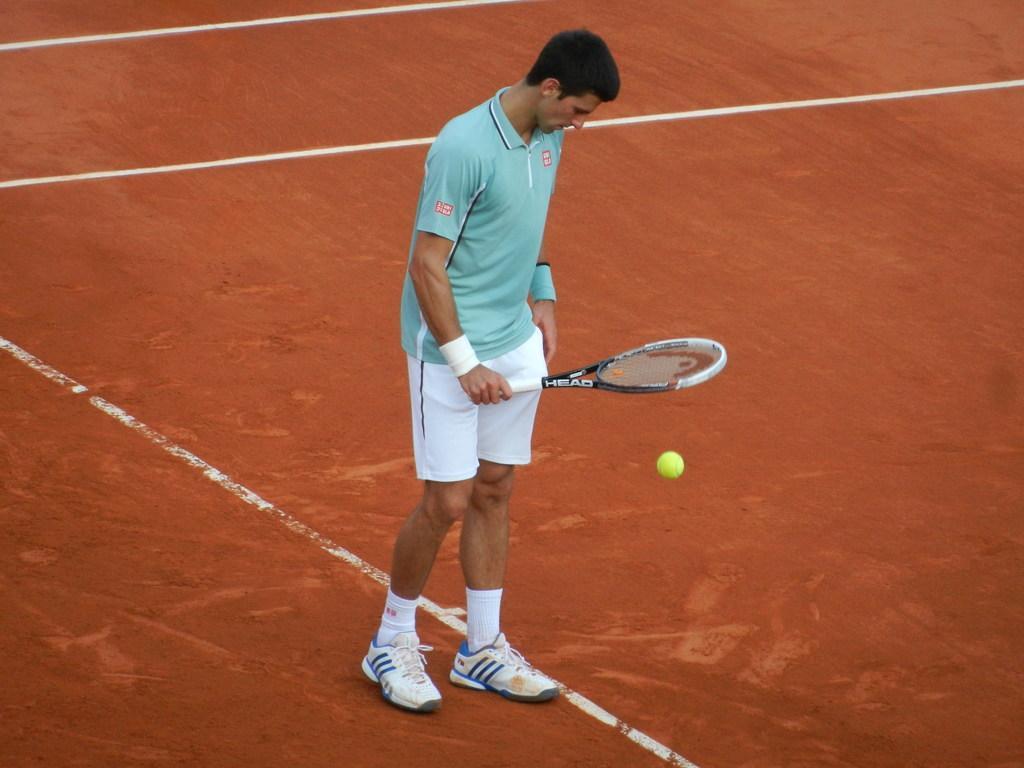Could you give a brief overview of what you see in this image? The man in blue T-shirt who is wearing shoes is holding a racket in his hand. I think he is playing tennis. In front of him, we see a tennis ball. In the background, it is red in color. This picture might be clicked in the tennis court. 